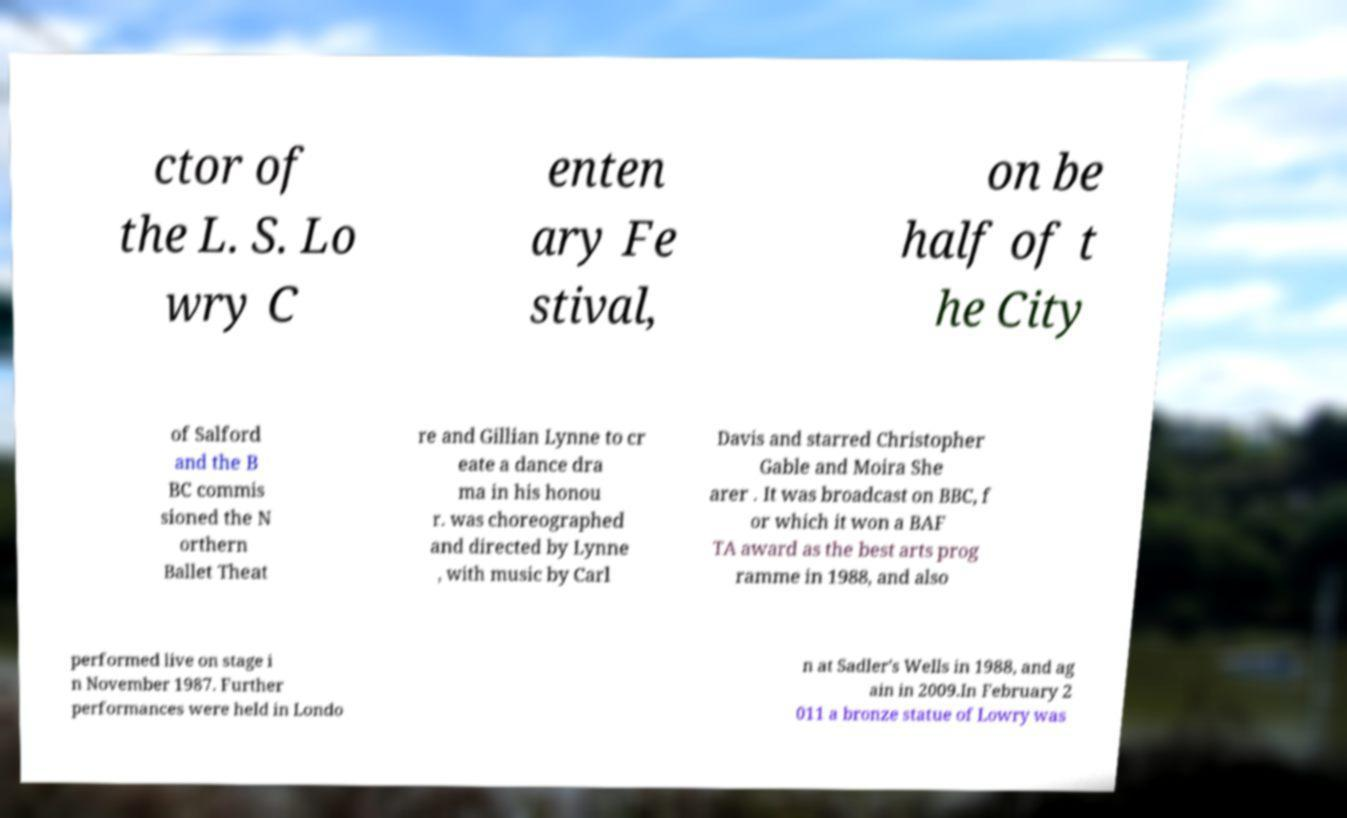Can you read and provide the text displayed in the image?This photo seems to have some interesting text. Can you extract and type it out for me? ctor of the L. S. Lo wry C enten ary Fe stival, on be half of t he City of Salford and the B BC commis sioned the N orthern Ballet Theat re and Gillian Lynne to cr eate a dance dra ma in his honou r. was choreographed and directed by Lynne , with music by Carl Davis and starred Christopher Gable and Moira She arer . It was broadcast on BBC, f or which it won a BAF TA award as the best arts prog ramme in 1988, and also performed live on stage i n November 1987. Further performances were held in Londo n at Sadler's Wells in 1988, and ag ain in 2009.In February 2 011 a bronze statue of Lowry was 